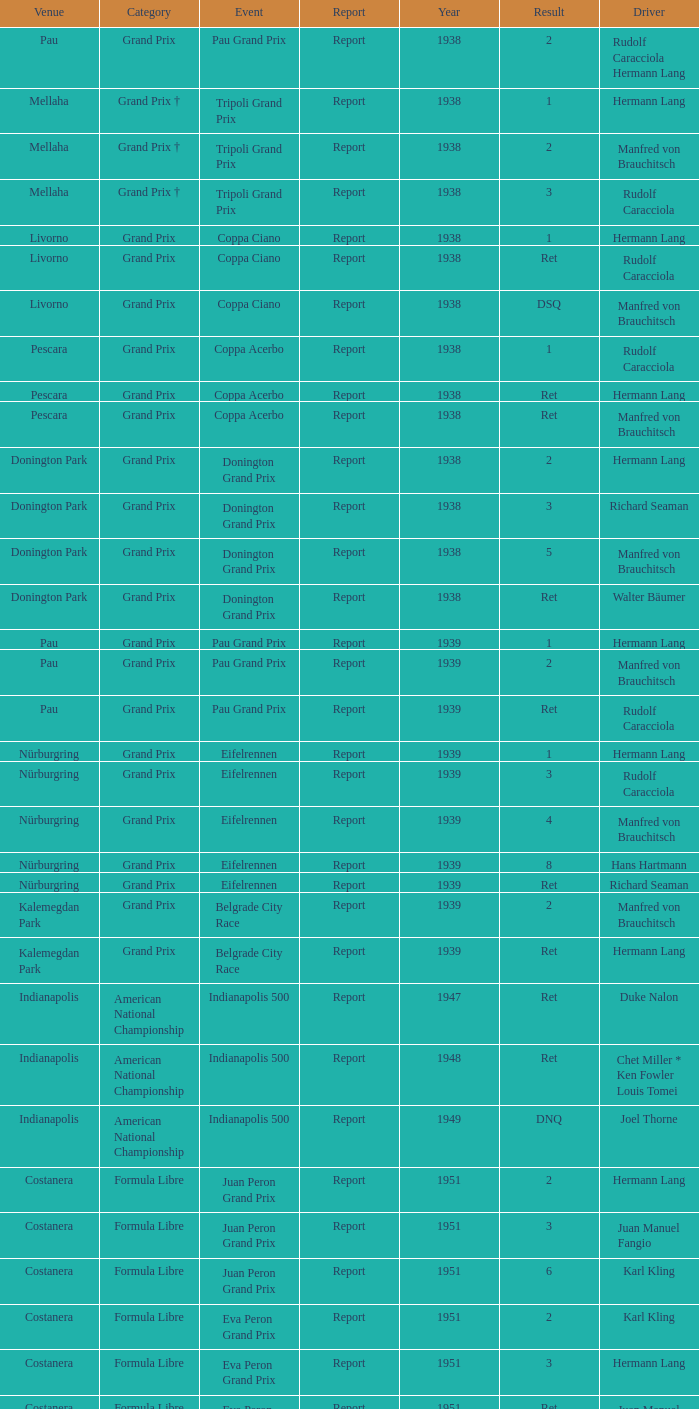When did Hans Hartmann drive? 1.0. 